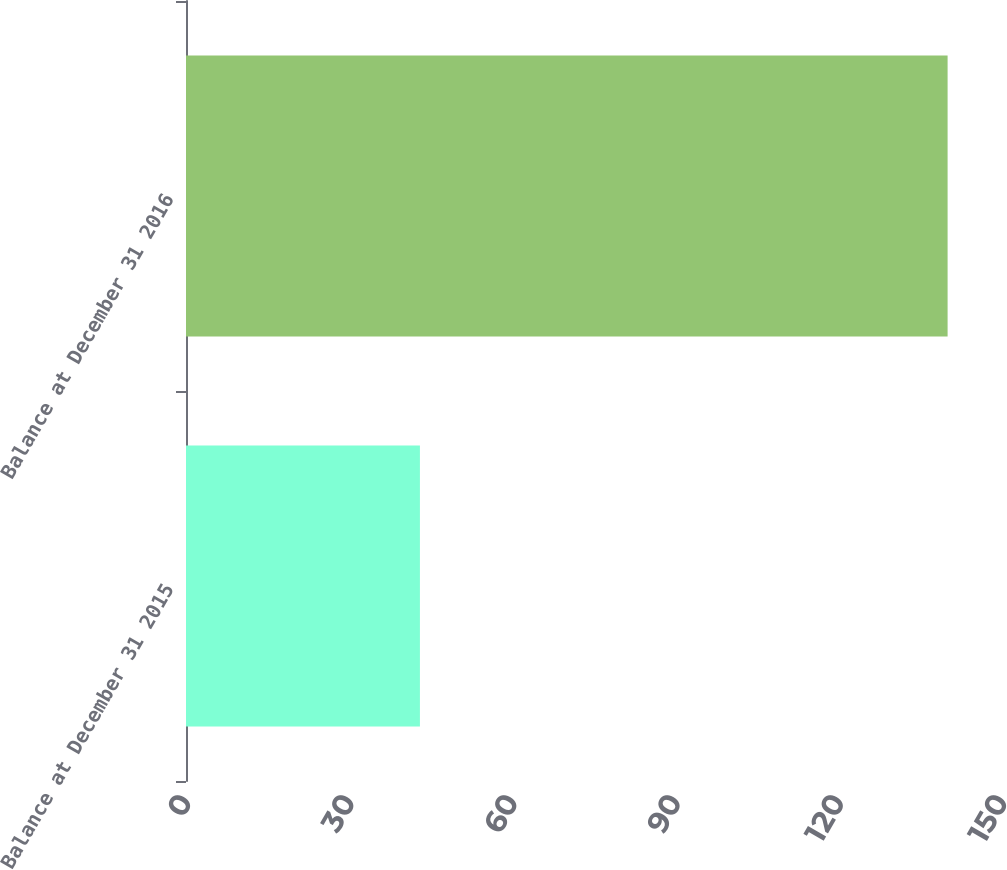<chart> <loc_0><loc_0><loc_500><loc_500><bar_chart><fcel>Balance at December 31 2015<fcel>Balance at December 31 2016<nl><fcel>43<fcel>140<nl></chart> 